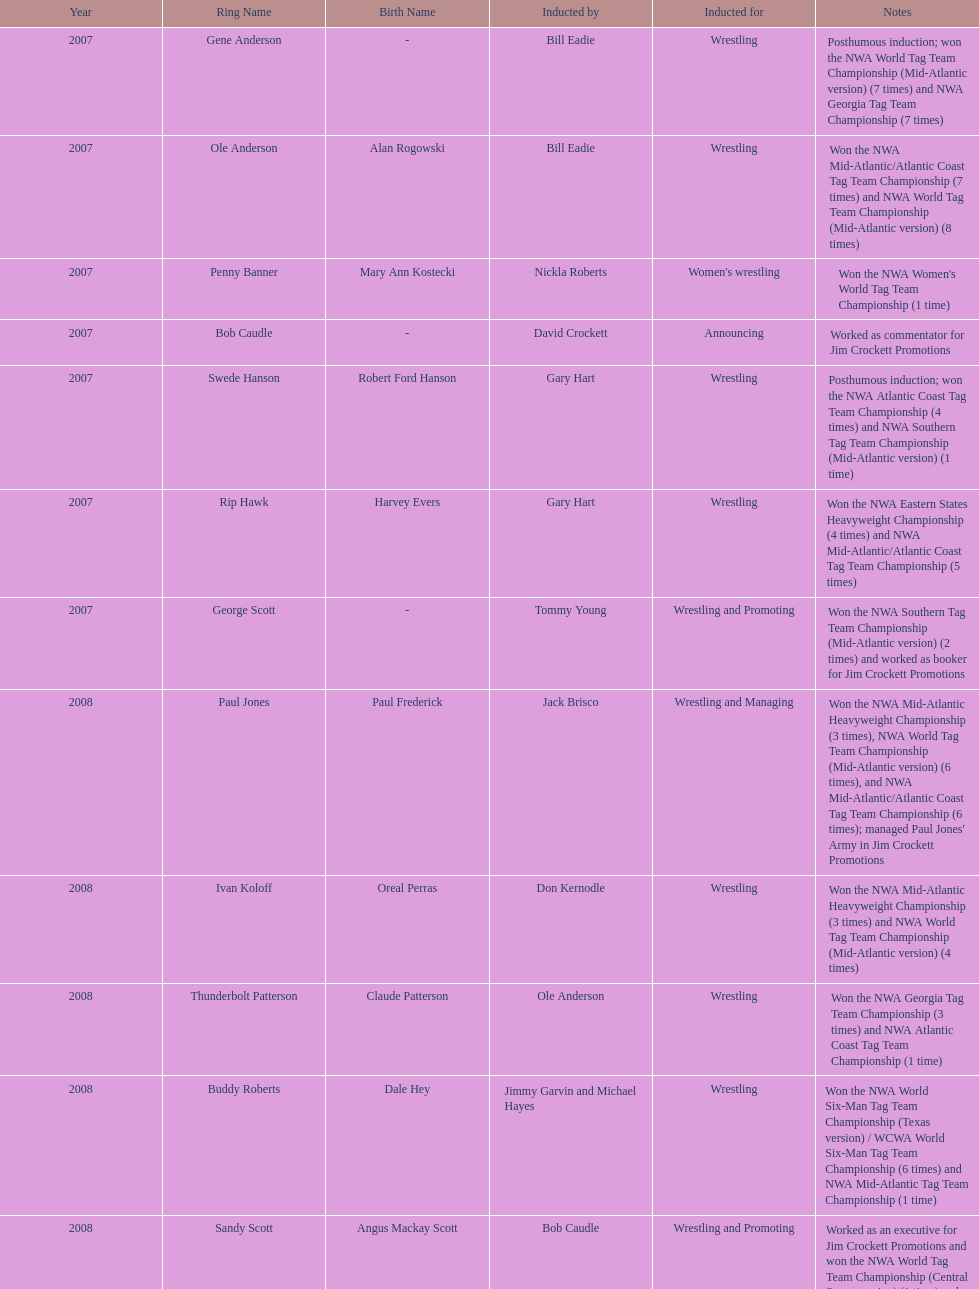What number of members were inducted before 2009? 14. 